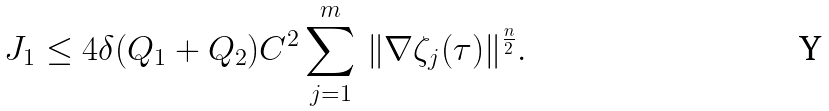Convert formula to latex. <formula><loc_0><loc_0><loc_500><loc_500>J _ { 1 } \leq 4 \delta ( Q _ { 1 } + Q _ { 2 } ) C ^ { 2 } \sum _ { j = 1 } ^ { m } \, \| \nabla \zeta _ { j } ( \tau ) \| ^ { \frac { n } { 2 } } .</formula> 